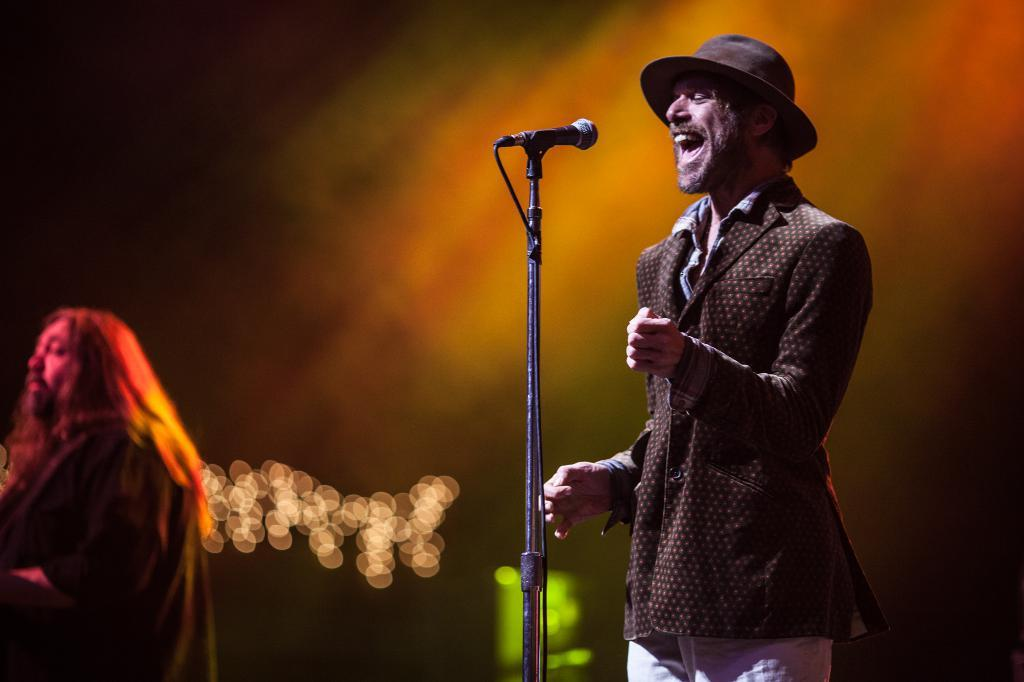How many people are present in the image? There are two people in the image. What object can be seen in the image that is typically used for amplifying sound? There is a mic in the image. What can be seen in the background of the image? There are lights in the background of the image. How would you describe the background of the image? The background of the image is blurred. What type of plate is being used by the fireman in the image? There is no fireman or plate present in the image. How does the camp in the image affect the lighting? There is no camp present in the image, so it cannot affect the lighting. 